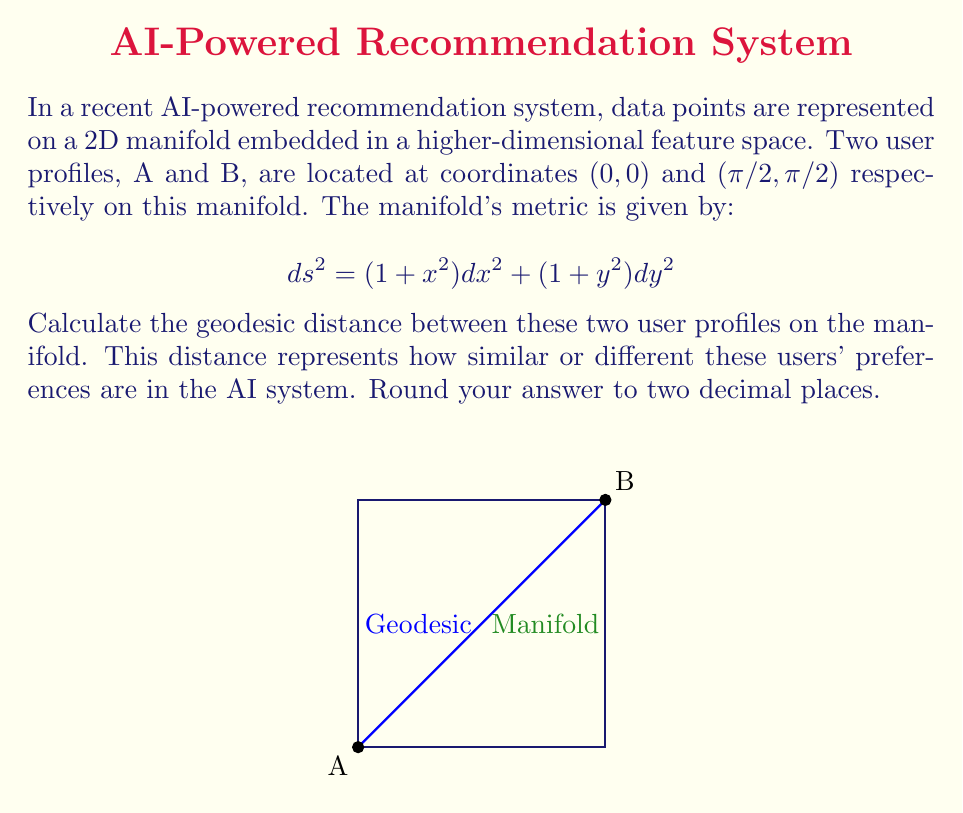Provide a solution to this math problem. To find the geodesic distance between two points on a manifold, we need to solve the geodesic equation. However, for this specific problem, we can use a simpler approach:

1) The metric is given by:
   $$ds^2 = (1 + x^2) dx^2 + (1 + y^2) dy^2$$

2) To find the geodesic distance, we need to integrate:
   $$d = \int_A^B \sqrt{(1 + x^2) (\frac{dx}{dt})^2 + (1 + y^2) (\frac{dy}{dt})^2} dt$$

3) Given the symmetry of the problem (both x and y go from 0 to π/2), we can assume that the geodesic will follow x = y. This simplifies our integral:
   $$d = \int_0^{\pi/2} \sqrt{(1 + x^2) + (1 + x^2)} dx = \int_0^{\pi/2} \sqrt{2(1 + x^2)} dx$$

4) Simplify:
   $$d = \sqrt{2} \int_0^{\pi/2} \sqrt{1 + x^2} dx$$

5) This integral can be solved using the substitution x = tan(θ):
   $$d = \sqrt{2} [\ln(x + \sqrt{1 + x^2})]_0^{\pi/2}$$

6) Evaluate:
   $$d = \sqrt{2} [\ln(\frac{\pi}{2} + \sqrt{1 + (\frac{\pi}{2})^2}) - \ln(1)]$$

7) Simplify and calculate:
   $$d = \sqrt{2} \ln(\frac{\pi}{2} + \sqrt{1 + \frac{\pi^2}{4}}) \approx 2.58$$

8) Rounding to two decimal places:
   $$d \approx 2.58$$
Answer: $2.58$ 